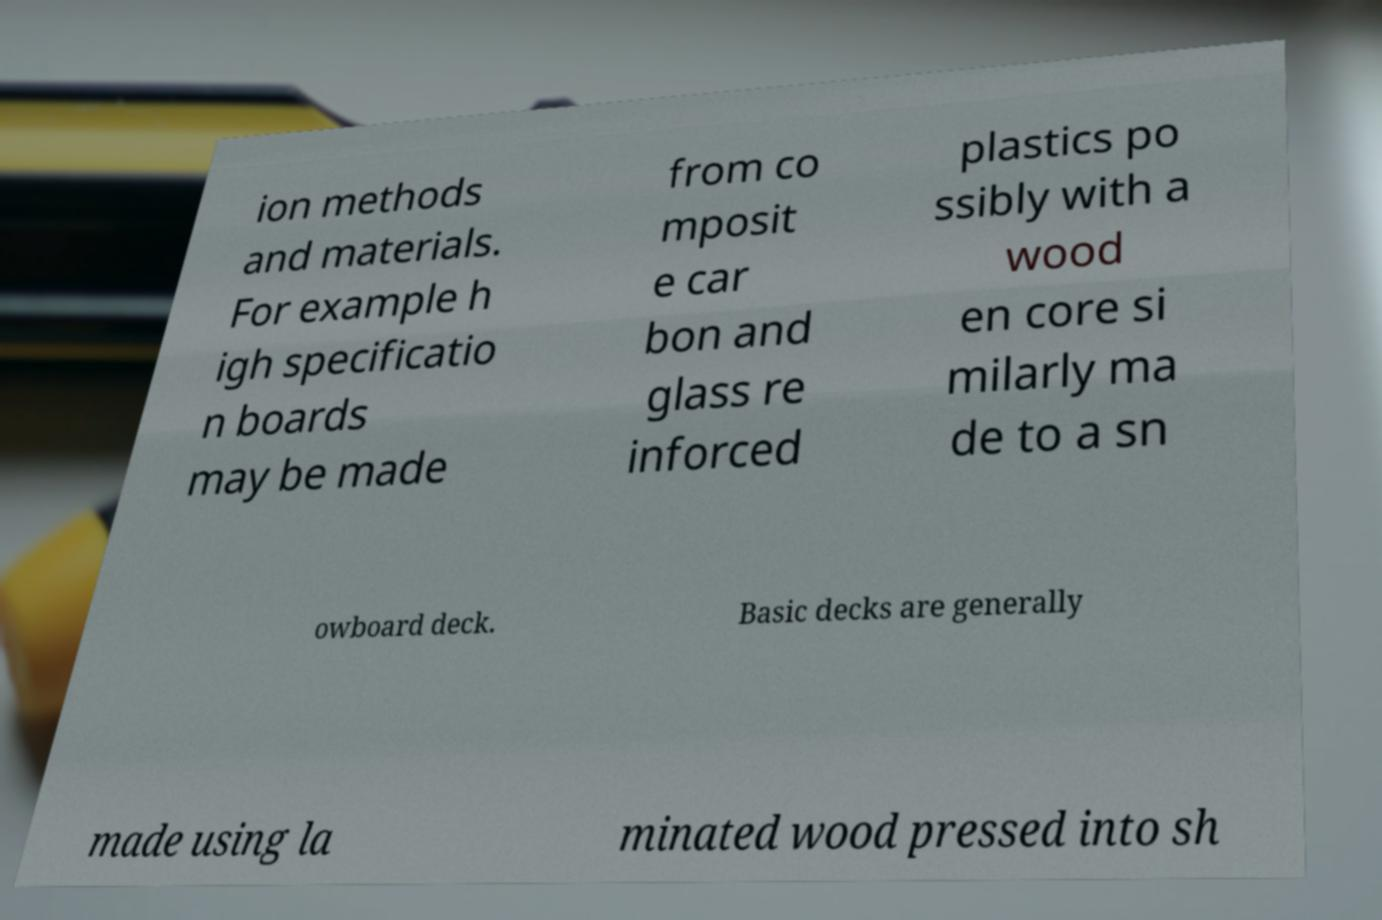Please identify and transcribe the text found in this image. ion methods and materials. For example h igh specificatio n boards may be made from co mposit e car bon and glass re inforced plastics po ssibly with a wood en core si milarly ma de to a sn owboard deck. Basic decks are generally made using la minated wood pressed into sh 